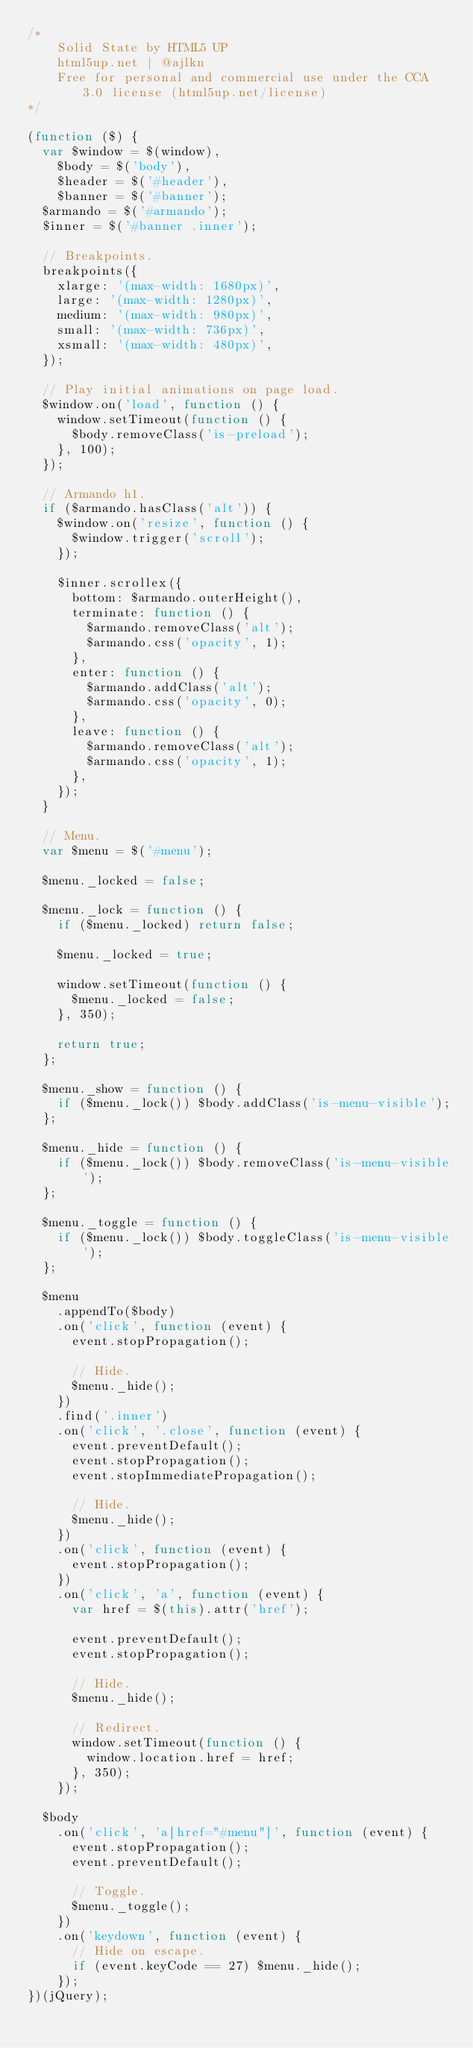<code> <loc_0><loc_0><loc_500><loc_500><_JavaScript_>/*
	Solid State by HTML5 UP
	html5up.net | @ajlkn
	Free for personal and commercial use under the CCA 3.0 license (html5up.net/license)
*/

(function ($) {
  var $window = $(window),
    $body = $('body'),
    $header = $('#header'),
    $banner = $('#banner');
  $armando = $('#armando');
  $inner = $('#banner .inner');

  // Breakpoints.
  breakpoints({
    xlarge: '(max-width: 1680px)',
    large: '(max-width: 1280px)',
    medium: '(max-width: 980px)',
    small: '(max-width: 736px)',
    xsmall: '(max-width: 480px)',
  });

  // Play initial animations on page load.
  $window.on('load', function () {
    window.setTimeout(function () {
      $body.removeClass('is-preload');
    }, 100);
  });

  // Armando h1.
  if ($armando.hasClass('alt')) {
    $window.on('resize', function () {
      $window.trigger('scroll');
    });

    $inner.scrollex({
      bottom: $armando.outerHeight(),
      terminate: function () {
        $armando.removeClass('alt');
        $armando.css('opacity', 1);
      },
      enter: function () {
        $armando.addClass('alt');
        $armando.css('opacity', 0);
      },
      leave: function () {
        $armando.removeClass('alt');
        $armando.css('opacity', 1);
      },
    });
  }

  // Menu.
  var $menu = $('#menu');

  $menu._locked = false;

  $menu._lock = function () {
    if ($menu._locked) return false;

    $menu._locked = true;

    window.setTimeout(function () {
      $menu._locked = false;
    }, 350);

    return true;
  };

  $menu._show = function () {
    if ($menu._lock()) $body.addClass('is-menu-visible');
  };

  $menu._hide = function () {
    if ($menu._lock()) $body.removeClass('is-menu-visible');
  };

  $menu._toggle = function () {
    if ($menu._lock()) $body.toggleClass('is-menu-visible');
  };

  $menu
    .appendTo($body)
    .on('click', function (event) {
      event.stopPropagation();

      // Hide.
      $menu._hide();
    })
    .find('.inner')
    .on('click', '.close', function (event) {
      event.preventDefault();
      event.stopPropagation();
      event.stopImmediatePropagation();

      // Hide.
      $menu._hide();
    })
    .on('click', function (event) {
      event.stopPropagation();
    })
    .on('click', 'a', function (event) {
      var href = $(this).attr('href');

      event.preventDefault();
      event.stopPropagation();

      // Hide.
      $menu._hide();

      // Redirect.
      window.setTimeout(function () {
        window.location.href = href;
      }, 350);
    });

  $body
    .on('click', 'a[href="#menu"]', function (event) {
      event.stopPropagation();
      event.preventDefault();

      // Toggle.
      $menu._toggle();
    })
    .on('keydown', function (event) {
      // Hide on escape.
      if (event.keyCode == 27) $menu._hide();
    });
})(jQuery);
</code> 